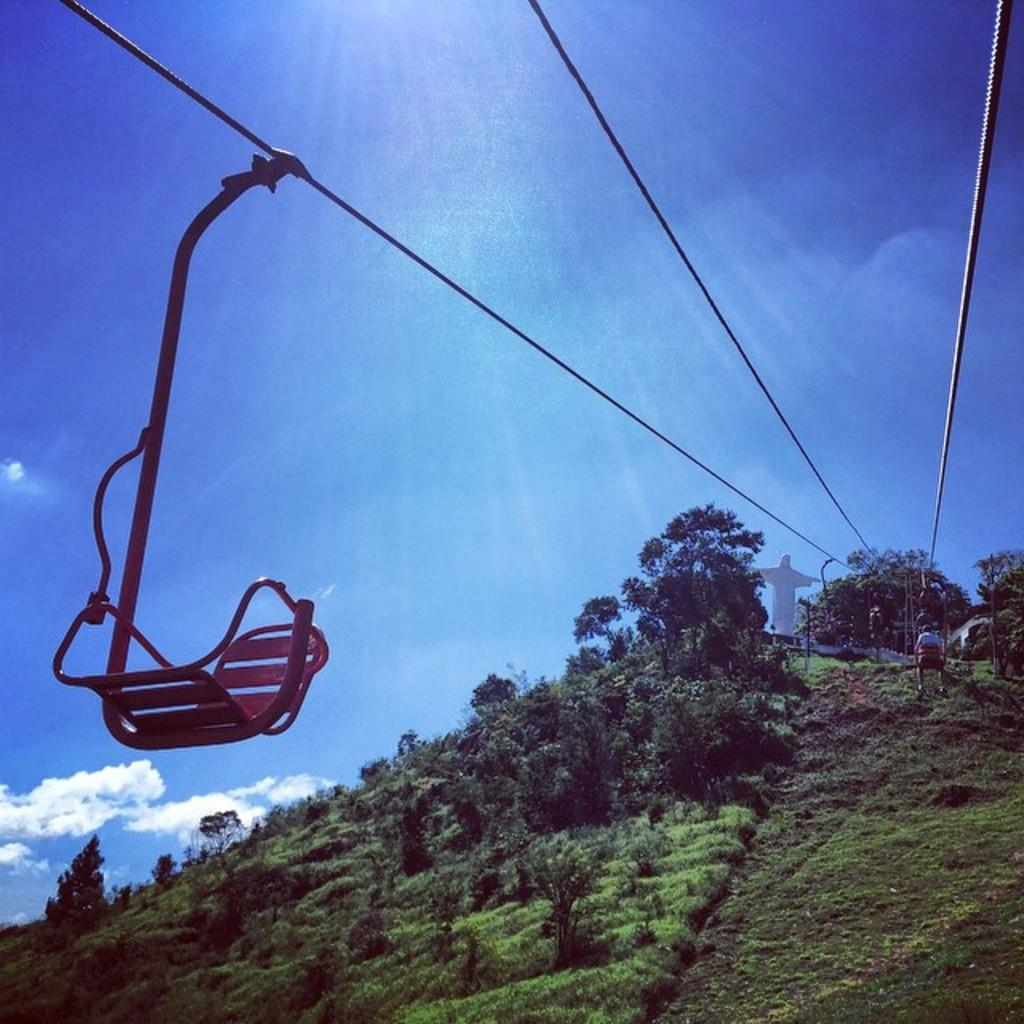What type of landscape feature is present in the image? There is a hill in the image. What type of vegetation can be seen in the image? There are trees and grass in the image. What mode of transportation is visible in the image? There is a ropeway in the image. Are there any people in the image? Yes, there are persons in the image. What other structures or objects can be seen in the image? There is a statue in the image. What is visible in the sky in the image? The sky is visible in the image, and there are clouds in the sky. What type of fruit is being harvested by the person wearing a hat in the image? There is no person wearing a hat or harvesting fruit in the image. What type of plough is being used to cultivate the land in the image? There is no plough present in the image. 